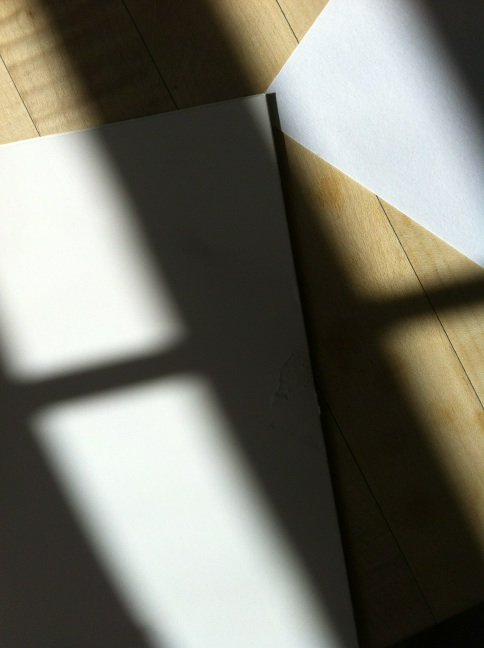Can you suggest how this setting might be used in a photography project? This setting, with its dramatic lighting and stark contrast between light and shadow, can be effectively used in a photography project to explore themes of isolation, contrast, or mystery. Photographers might manipulate such lighting conditions to create moody, evocative compositions that evoke an emotional response from viewers. 